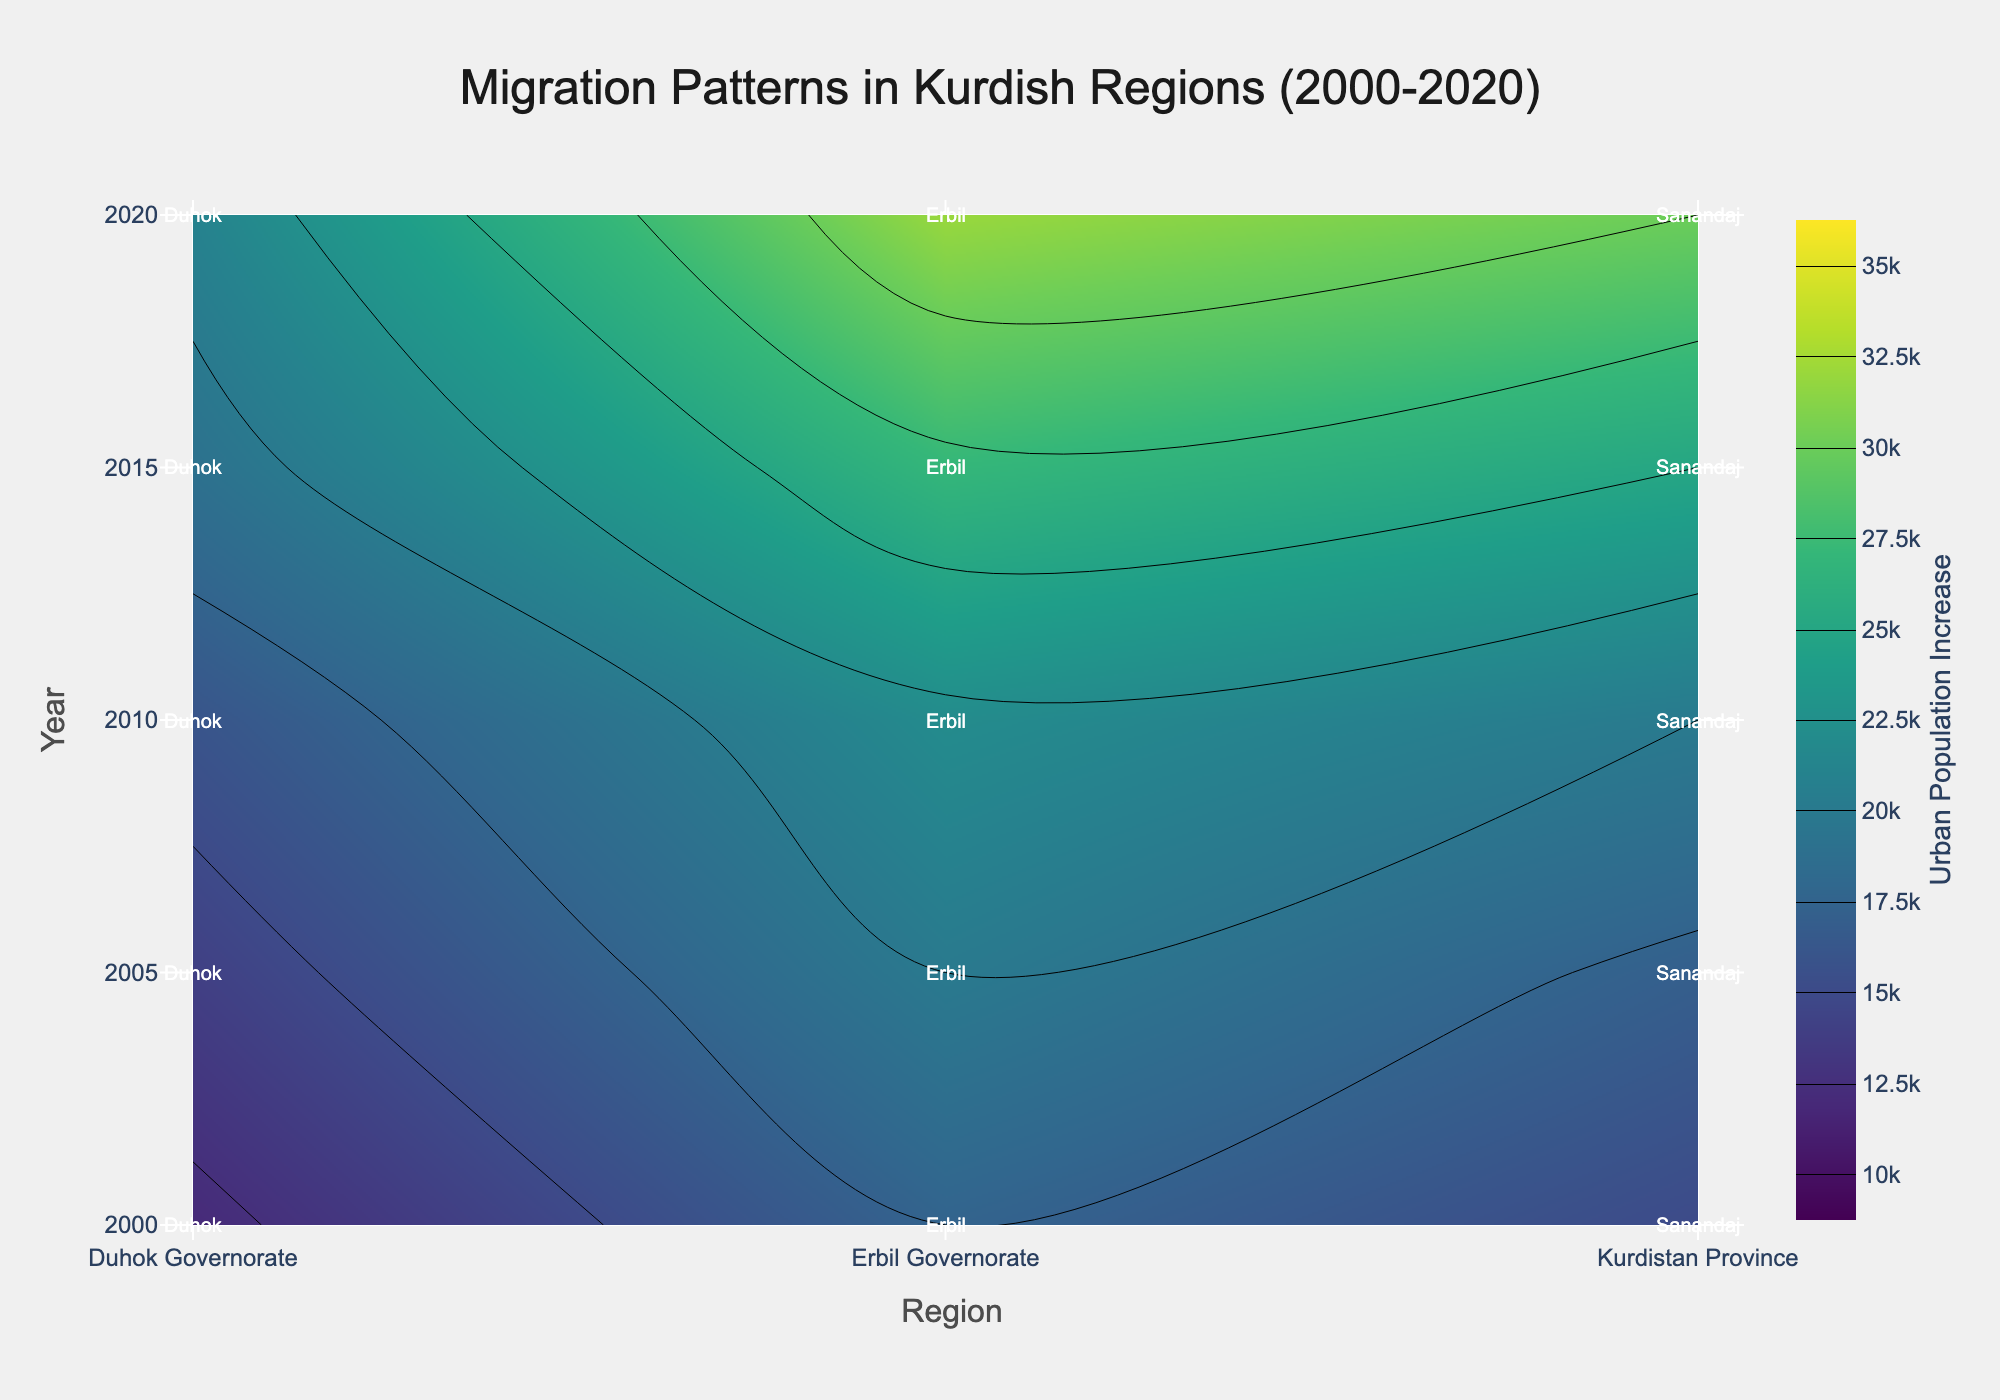What is the title of the figure? The title of the figure can be found at the top and provides an overview of the subject of the graph. Look at the top of the plot for the main heading.
Answer: Migration Patterns in Kurdish Regions (2000-2020) Which region shows the largest increase in urban population in 2020? Find the year 2020 on the y-axis, then look for the highest value on the contour plot corresponding to that year.
Answer: Erbil Governorate In which year did Sanandaj see an urban population increase of 25,000? Locate the “Sanandaj” label on the plot. Then find the contour line or color area that corresponds to 25,000 for that region and trace it to the year on the y-axis.
Answer: 2015 Compare the urban population increase in Erbil from 2000 to 2020. Which year had the highest increase? Find the points on the y-axis for the years 2000 and 2020 for Erbil, then compare the values indicated by the colors or contour lines for those years to determine which is higher.
Answer: 2020 What was the increase in urban population for Duhok in 2010? Locate the “Duhok” label on the plot. Then find the contour line or color area that corresponds to the value in 2010 by tracing it back to the y-axis.
Answer: 16,000 Which region showed the least increase in urban population in 2000? Find the year 2000 on the y-axis, then look for the lowest value on the contour plot corresponding to that year.
Answer: Duhok Governorate On average, how much did the urban population increase in Sanandaj each year between 2000 and 2020? Extract the values for Sanandaj for the years 2000, 2005, 2010, 2015, and 2020, sum them up and divide by the number of years to find the average.
Answer: (15000 + 17000 + 20000 + 25000 + 30000) / 5 = 21,000 Which year shows the steepest increase in urban population across all regions? Observe the contour plot and identify the year with the most significant shift in the contour levels across regions, indicating a steep overall increase.
Answer: 2020 How does the increase in urban population in Duhok in 2015 compare to that in the Kurdistan Province the same year? Locate the year 2015 on the y-axis, then compare the contour levels or colors corresponding to “Duhok” and “Kurdistan Province” to determine which is higher and by how much.
Answer: Kurdistan Province has 6,000 more What were the key urban areas represented in the figure? Check the annotations added to the plot for each region to identify the cities named as key urban areas.
Answer: Sanandaj, Erbil, Duhok 